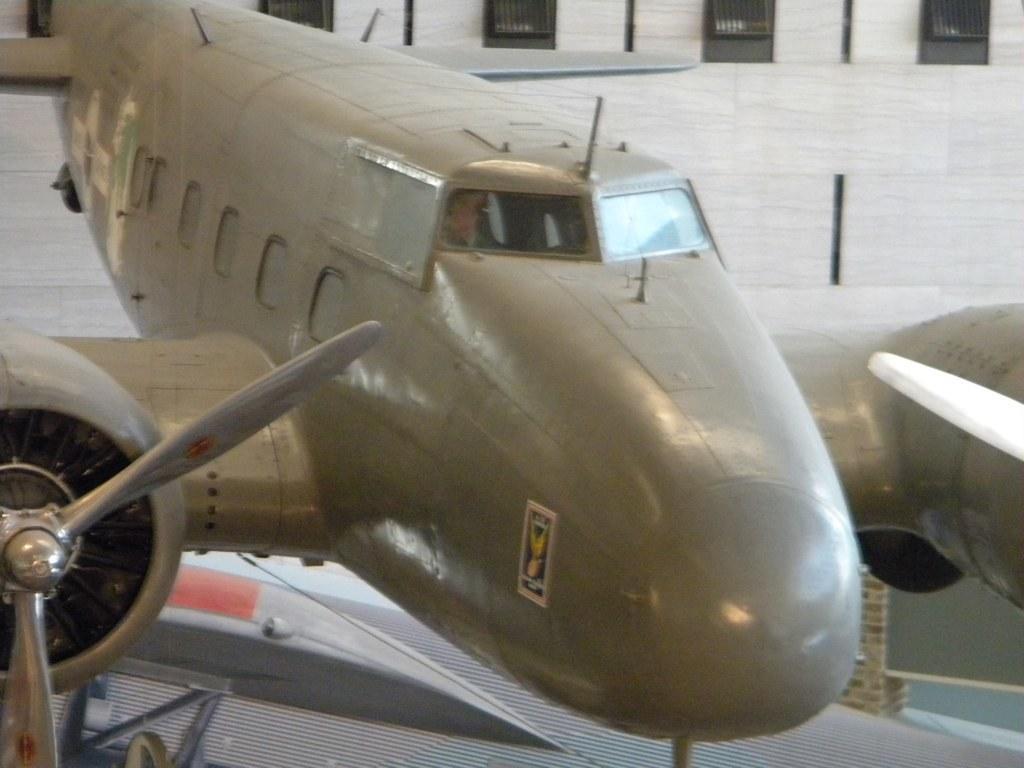How would you summarize this image in a sentence or two? In this image we can see an aeroplane on the floor. In the background there are grills. 